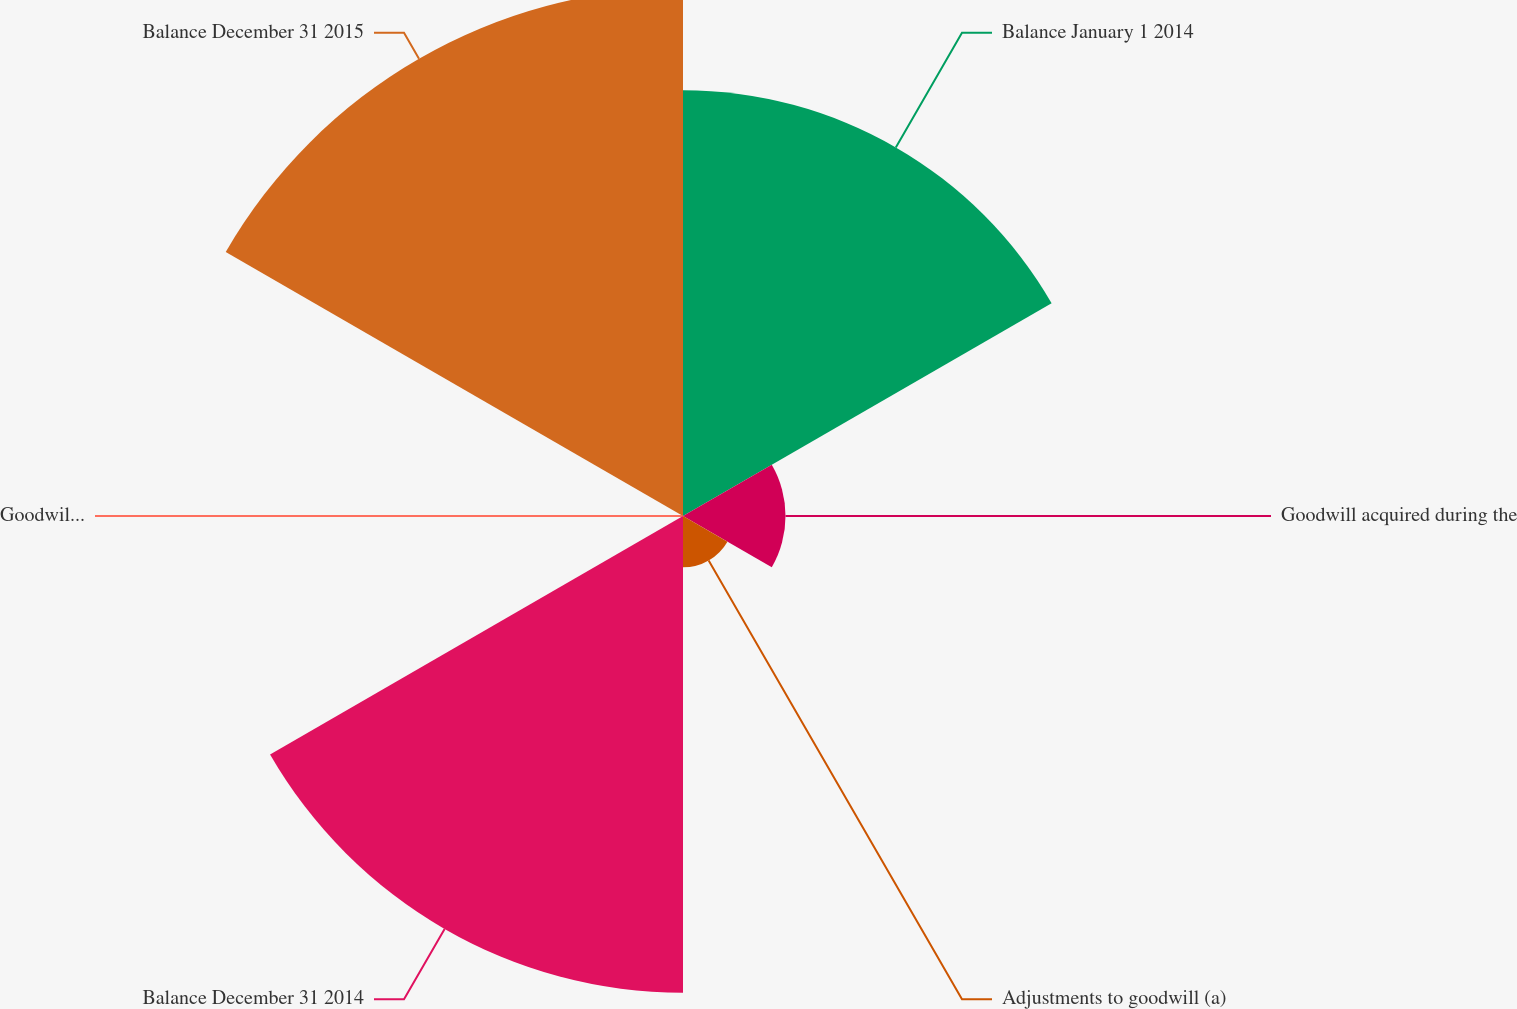<chart> <loc_0><loc_0><loc_500><loc_500><pie_chart><fcel>Balance January 1 2014<fcel>Goodwill acquired during the<fcel>Adjustments to goodwill (a)<fcel>Balance December 31 2014<fcel>Goodwill divested during the<fcel>Balance December 31 2015<nl><fcel>26.86%<fcel>6.47%<fcel>3.24%<fcel>30.09%<fcel>0.02%<fcel>33.32%<nl></chart> 